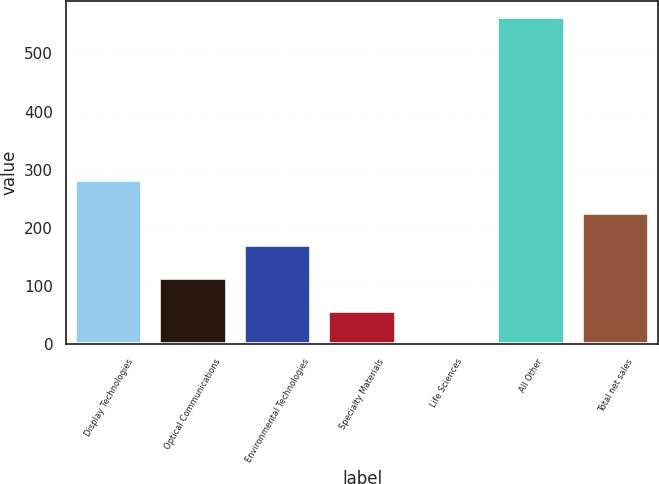<chart> <loc_0><loc_0><loc_500><loc_500><bar_chart><fcel>Display Technologies<fcel>Optical Communications<fcel>Environmental Technologies<fcel>Specialty Materials<fcel>Life Sciences<fcel>All Other<fcel>Total net sales<nl><fcel>282<fcel>113.4<fcel>169.6<fcel>57.2<fcel>1<fcel>563<fcel>225.8<nl></chart> 